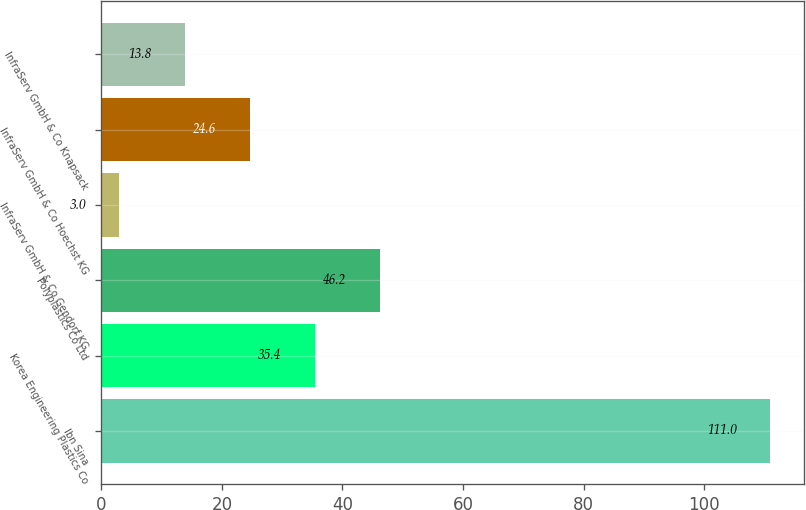Convert chart. <chart><loc_0><loc_0><loc_500><loc_500><bar_chart><fcel>Ibn Sina<fcel>Korea Engineering Plastics Co<fcel>Polyplastics Co Ltd<fcel>InfraServ GmbH & Co Gendorf KG<fcel>InfraServ GmbH & Co Hoechst KG<fcel>InfraServ GmbH & Co Knapsack<nl><fcel>111<fcel>35.4<fcel>46.2<fcel>3<fcel>24.6<fcel>13.8<nl></chart> 